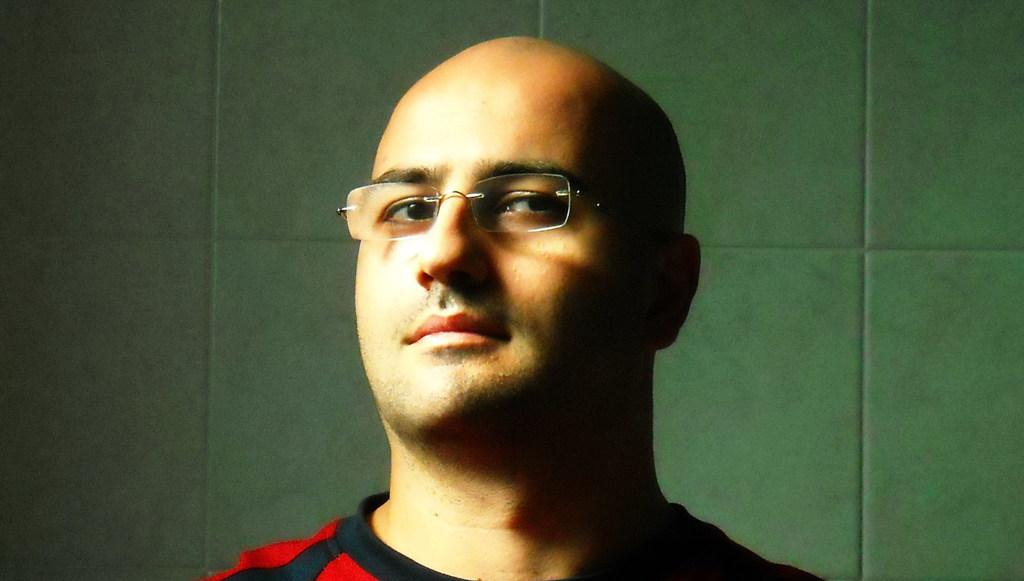What is present in the image? There is a man in the image. Can you describe the man's appearance? The man is wearing spectacles. What is visible in the background of the image? There is a wall visible behind the man in the image. What type of vest is the owl wearing in the image? There is no owl or vest present in the image. What time does the watch in the image show? There is no watch present in the image. 